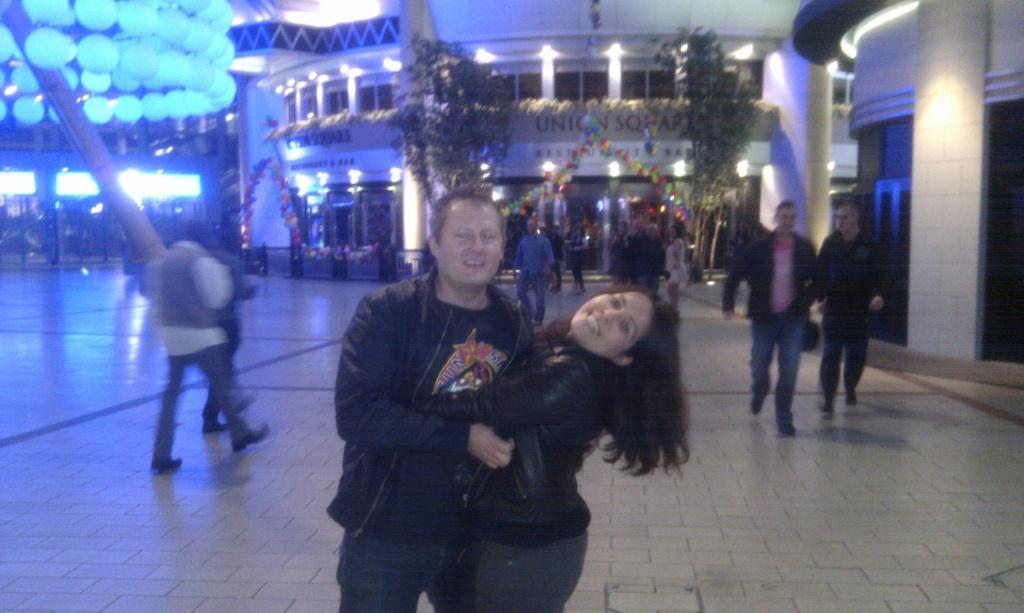Can you describe this image briefly? In this image in the middle, there is a man, he wears a jacket, trouser, he is smiling and there is a woman, she wears a jacket, trouser, her hair is short, she is smiling. On the right, there are two men, and they are walking. On the left there are two people, they are walking. In the background there are some people, lights, building, decorations, wall and floor. 